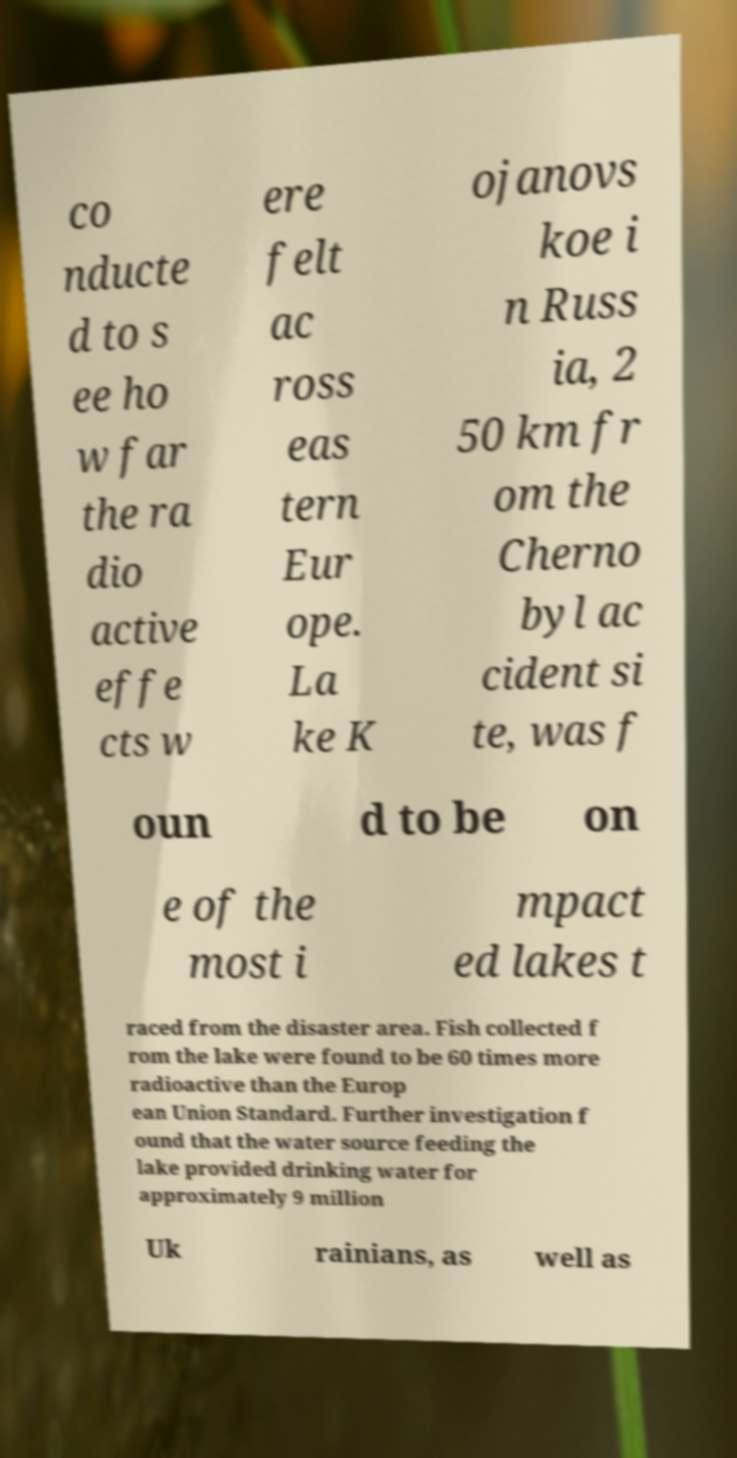Can you accurately transcribe the text from the provided image for me? co nducte d to s ee ho w far the ra dio active effe cts w ere felt ac ross eas tern Eur ope. La ke K ojanovs koe i n Russ ia, 2 50 km fr om the Cherno byl ac cident si te, was f oun d to be on e of the most i mpact ed lakes t raced from the disaster area. Fish collected f rom the lake were found to be 60 times more radioactive than the Europ ean Union Standard. Further investigation f ound that the water source feeding the lake provided drinking water for approximately 9 million Uk rainians, as well as 